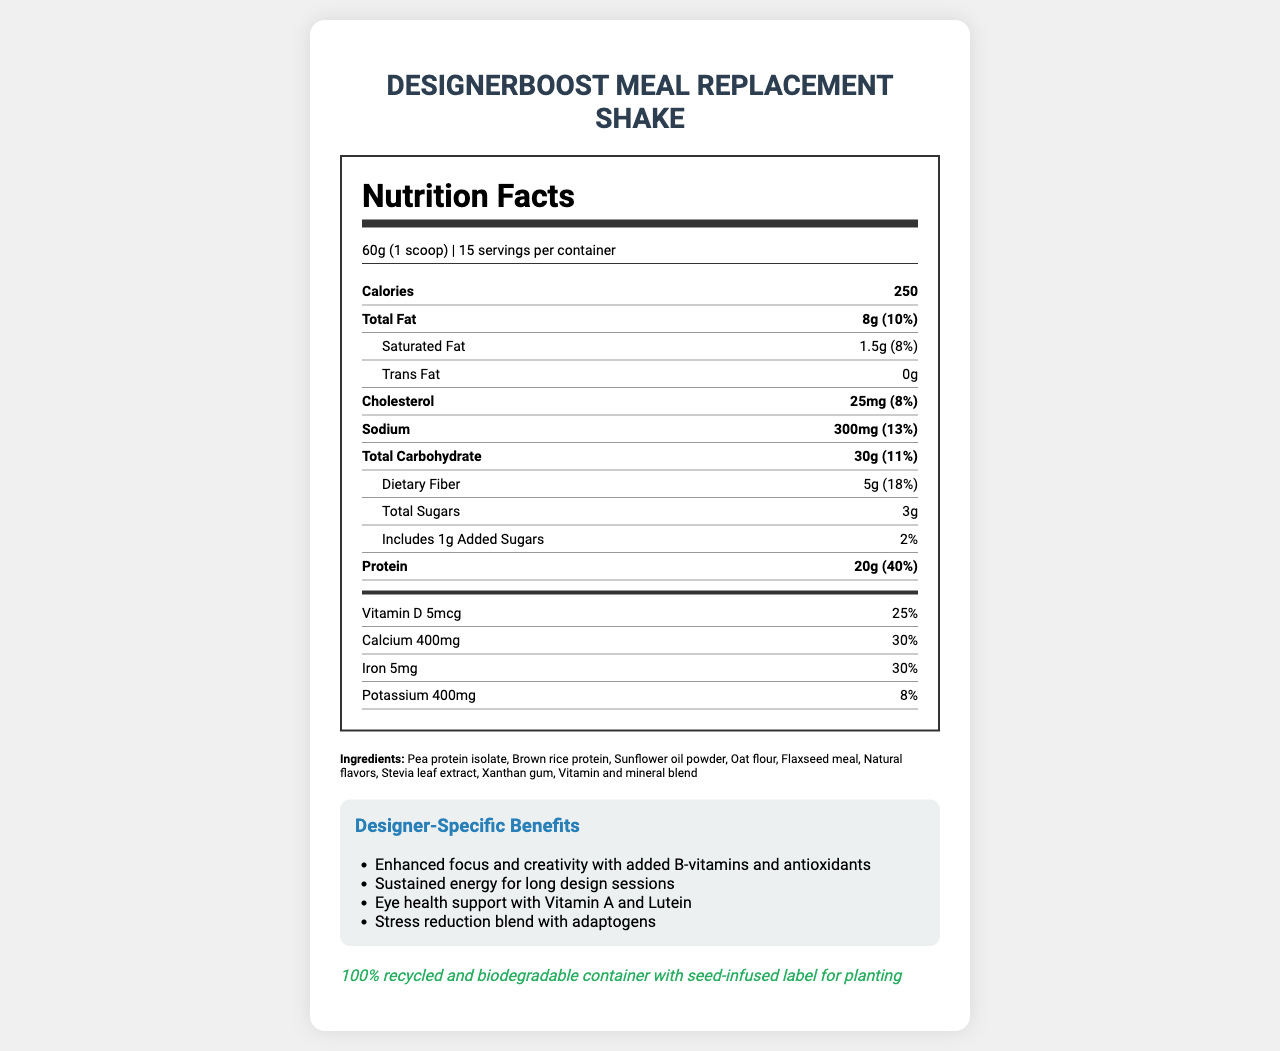How many calories are there in one serving of the meal replacement shake? The document states that each serving of DesignerBoost Meal Replacement Shake contains 250 calories.
Answer: 250 What is the serving size of the meal replacement shake? The serving size is specified as 60g (1 scoop) in the document.
Answer: 60g (1 scoop) How much protein does one serving provide? According to the nutritional details, one serving provides 20g of protein.
Answer: 20g What is the percentage of daily value for dietary fiber in one serving? The document lists the daily value for dietary fiber as 18%.
Answer: 18% How much calcium is included per serving and what percentage of the daily value does this represent? One serving includes 400mg of calcium, which represents 30% of the daily value.
Answer: 400mg, 30% How many servings are there in one container? A. 10 B. 15 C. 20 The document states that there are 15 servings per container.
Answer: B. 15 Which ingredient is not listed in the ingredient list? A. Pea protein isolate B. Brown rice protein C. Whey protein The ingredient list includes Pea protein isolate and Brown rice protein but not Whey protein.
Answer: C. Whey protein Does the meal replacement shake contain any added sugars? The document indicates that there is 1g of added sugars in each serving.
Answer: Yes What are two benefits specifically highlighted for designers? These are listed under 'Designer-Specific Benefits' in the document.
Answer: Enhanced focus and creativity with added B-vitamins and antioxidants, and eye health support with Vitamin A and Lutein Is the packaging eco-friendly? The document states that the packaging is 100% recycled and biodegradable, with a seed-infused label for planting.
Answer: Yes Summarize the main features of the DesignerBoost Meal Replacement Shake. This summary captures the key nutritional details, specialized benefits for designers, and the eco-friendly packaging of the meal replacement shake.
Answer: The DesignerBoost Meal Replacement Shake offers a comprehensive nutritional profile suitable for designers, with 250 calories per serving, 20g of protein, and significant amounts of essential vitamins and minerals. It includes designer-specific benefits like enhanced focus and sustained energy. The packaging is eco-friendly, and interactive elements like a QR code and augmented reality features are integrated for a richer experience. What is the source of the oat flour in the shake? The document does not provide information on the source of the oat flour.
Answer: Not enough information 